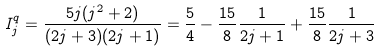Convert formula to latex. <formula><loc_0><loc_0><loc_500><loc_500>I _ { j } ^ { q } = \frac { 5 j ( j ^ { 2 } + 2 ) } { ( 2 j + 3 ) ( 2 j + 1 ) } = \frac { 5 } { 4 } - \frac { 1 5 } { 8 } \frac { 1 } { 2 j + 1 } + \frac { 1 5 } { 8 } \frac { 1 } { 2 j + 3 }</formula> 